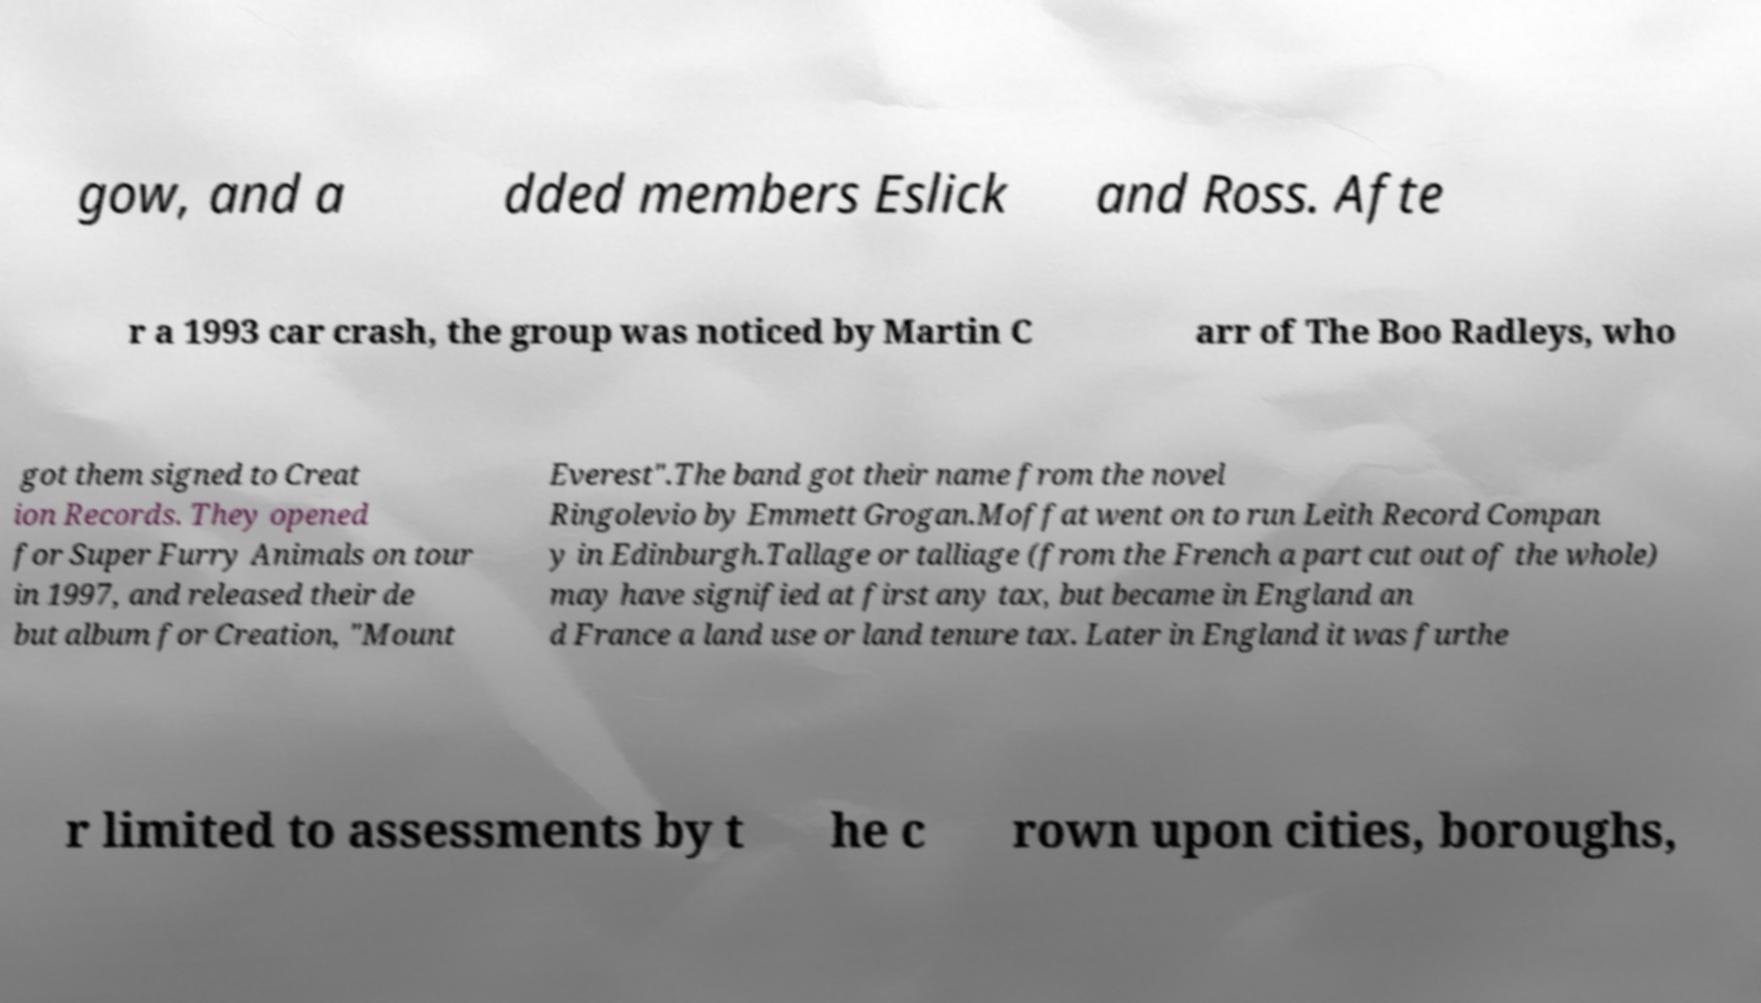Please read and relay the text visible in this image. What does it say? gow, and a dded members Eslick and Ross. Afte r a 1993 car crash, the group was noticed by Martin C arr of The Boo Radleys, who got them signed to Creat ion Records. They opened for Super Furry Animals on tour in 1997, and released their de but album for Creation, "Mount Everest".The band got their name from the novel Ringolevio by Emmett Grogan.Moffat went on to run Leith Record Compan y in Edinburgh.Tallage or talliage (from the French a part cut out of the whole) may have signified at first any tax, but became in England an d France a land use or land tenure tax. Later in England it was furthe r limited to assessments by t he c rown upon cities, boroughs, 